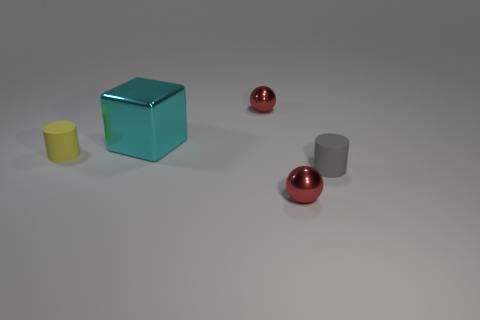Add 2 yellow objects. How many objects exist? 7 Subtract all cylinders. How many objects are left? 3 Subtract all small balls. Subtract all large shiny objects. How many objects are left? 2 Add 2 big cyan objects. How many big cyan objects are left? 3 Add 1 big cyan blocks. How many big cyan blocks exist? 2 Subtract 1 red spheres. How many objects are left? 4 